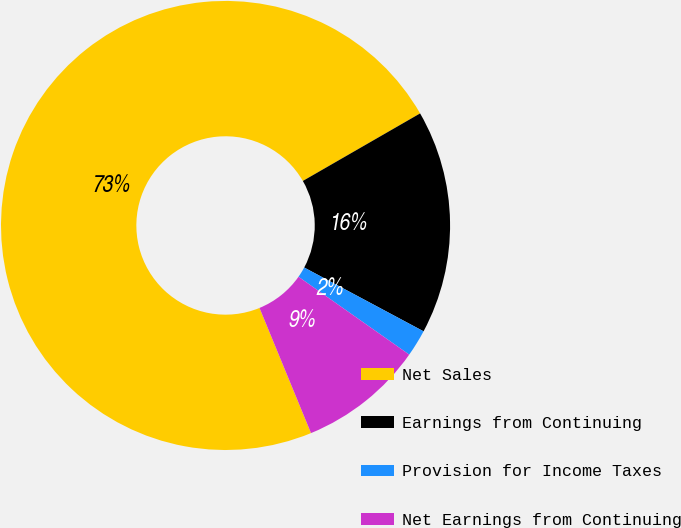Convert chart. <chart><loc_0><loc_0><loc_500><loc_500><pie_chart><fcel>Net Sales<fcel>Earnings from Continuing<fcel>Provision for Income Taxes<fcel>Net Earnings from Continuing<nl><fcel>72.9%<fcel>16.13%<fcel>1.94%<fcel>9.03%<nl></chart> 